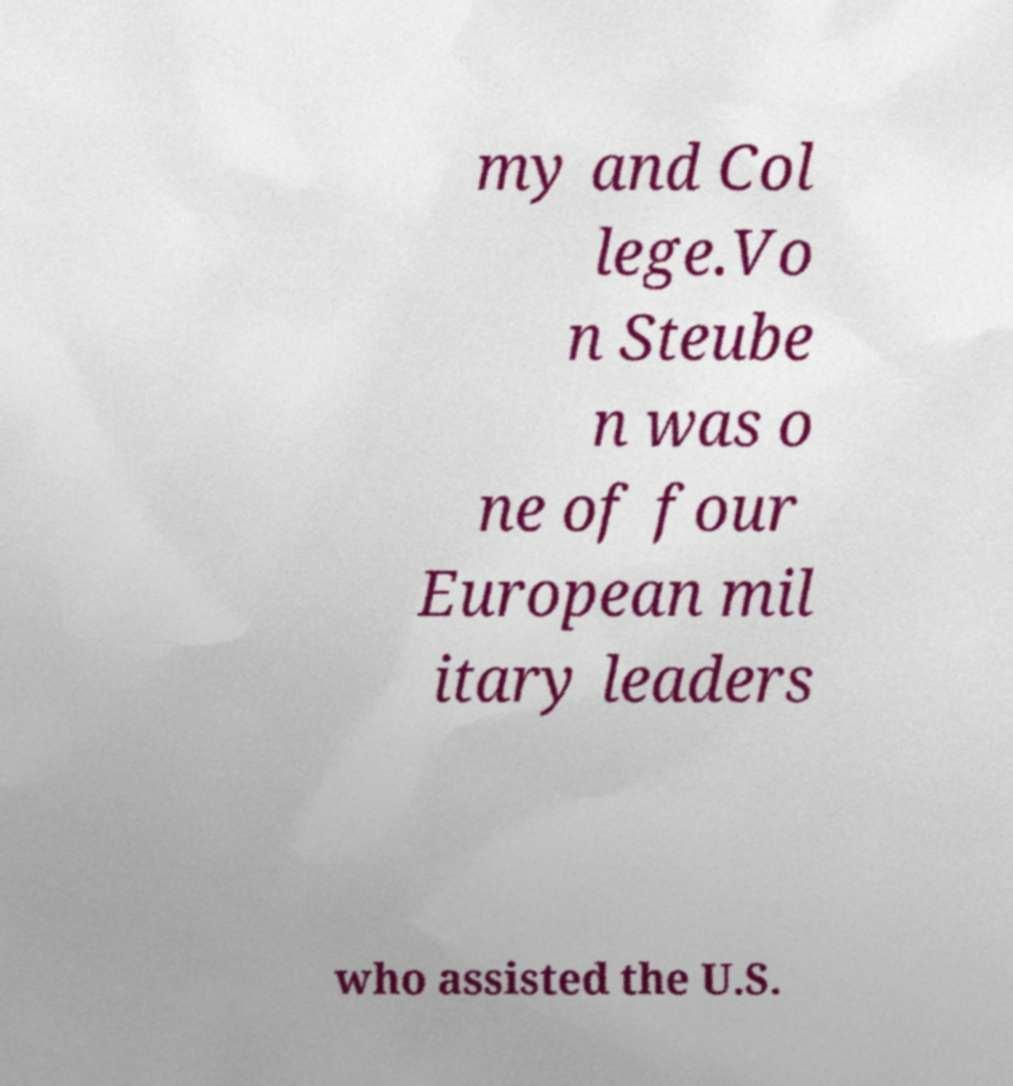I need the written content from this picture converted into text. Can you do that? my and Col lege.Vo n Steube n was o ne of four European mil itary leaders who assisted the U.S. 